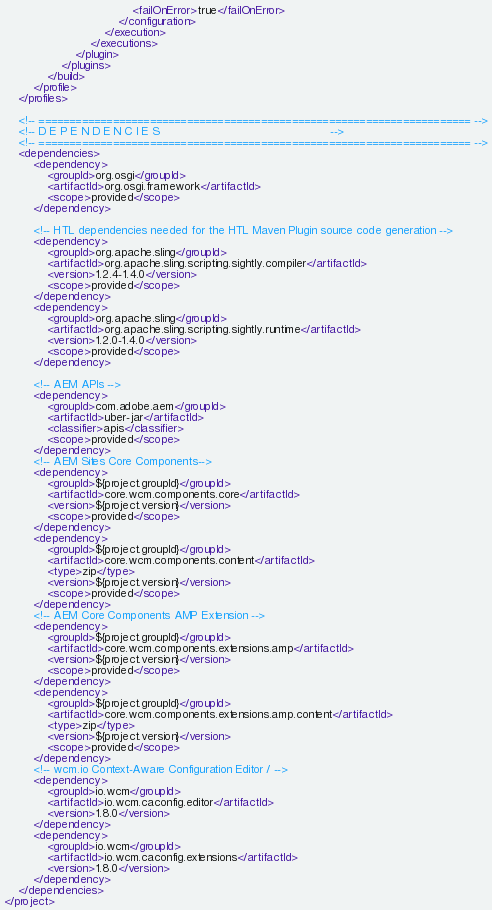Convert code to text. <code><loc_0><loc_0><loc_500><loc_500><_XML_>                                    <failOnError>true</failOnError>
                                </configuration>
                            </execution>
                        </executions>
                    </plugin>
                </plugins>
            </build>
        </profile>
    </profiles>

    <!-- ====================================================================== -->
    <!-- D E P E N D E N C I E S                                                -->
    <!-- ====================================================================== -->
    <dependencies>
        <dependency>
            <groupId>org.osgi</groupId>
            <artifactId>org.osgi.framework</artifactId>
            <scope>provided</scope>
        </dependency>

        <!-- HTL dependencies needed for the HTL Maven Plugin source code generation -->
        <dependency>
            <groupId>org.apache.sling</groupId>
            <artifactId>org.apache.sling.scripting.sightly.compiler</artifactId>
            <version>1.2.4-1.4.0</version>
            <scope>provided</scope>
        </dependency>
        <dependency>
            <groupId>org.apache.sling</groupId>
            <artifactId>org.apache.sling.scripting.sightly.runtime</artifactId>
            <version>1.2.0-1.4.0</version>
            <scope>provided</scope>
        </dependency>

        <!-- AEM APIs -->
        <dependency>
            <groupId>com.adobe.aem</groupId>
            <artifactId>uber-jar</artifactId>
            <classifier>apis</classifier>
            <scope>provided</scope>
        </dependency>
        <!-- AEM Sites Core Components-->
        <dependency>
            <groupId>${project.groupId}</groupId>
            <artifactId>core.wcm.components.core</artifactId>
            <version>${project.version}</version>
            <scope>provided</scope>
        </dependency>
        <dependency>
            <groupId>${project.groupId}</groupId>
            <artifactId>core.wcm.components.content</artifactId>
            <type>zip</type>
            <version>${project.version}</version>
            <scope>provided</scope>
        </dependency>
        <!-- AEM Core Components AMP Extension -->
        <dependency>
            <groupId>${project.groupId}</groupId>
            <artifactId>core.wcm.components.extensions.amp</artifactId>
            <version>${project.version}</version>
            <scope>provided</scope>
        </dependency>
        <dependency>
            <groupId>${project.groupId}</groupId>
            <artifactId>core.wcm.components.extensions.amp.content</artifactId>
            <type>zip</type>
            <version>${project.version}</version>
            <scope>provided</scope>
        </dependency>
        <!-- wcm.io Context-Aware Configuration Editor / -->
        <dependency>
            <groupId>io.wcm</groupId>
            <artifactId>io.wcm.caconfig.editor</artifactId>
            <version>1.8.0</version>
        </dependency>
        <dependency>
            <groupId>io.wcm</groupId>
            <artifactId>io.wcm.caconfig.extensions</artifactId>
            <version>1.8.0</version>
        </dependency>
    </dependencies>
</project>
</code> 